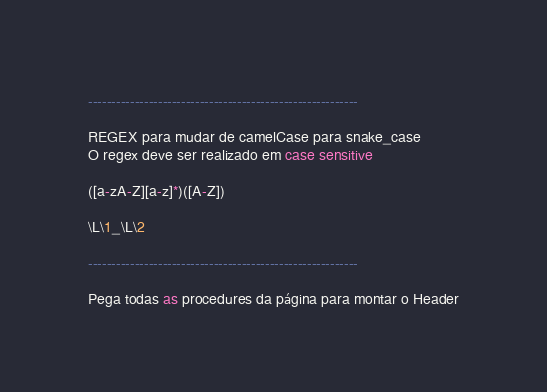Convert code to text. <code><loc_0><loc_0><loc_500><loc_500><_SQL_>
----------------------------------------------------------

REGEX para mudar de camelCase para snake_case
O regex deve ser realizado em case sensitive

([a-zA-Z][a-z]*)([A-Z])

\L\1_\L\2

----------------------------------------------------------

Pega todas as procedures da página para montar o Header
</code> 